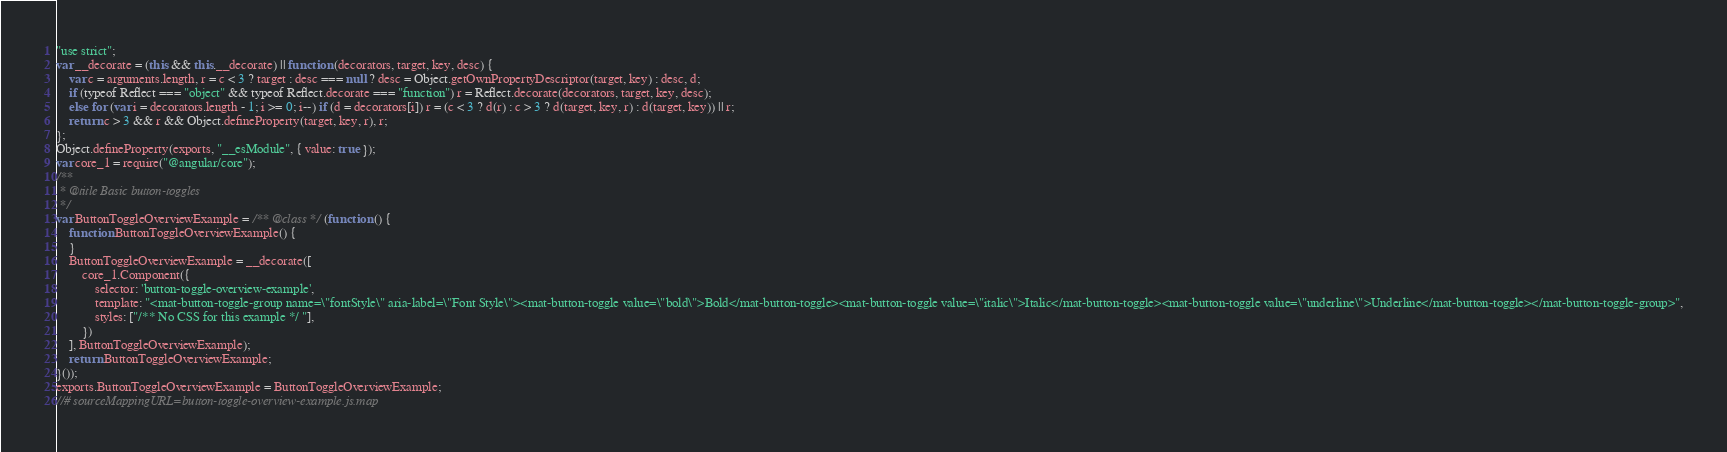Convert code to text. <code><loc_0><loc_0><loc_500><loc_500><_JavaScript_>"use strict";
var __decorate = (this && this.__decorate) || function (decorators, target, key, desc) {
    var c = arguments.length, r = c < 3 ? target : desc === null ? desc = Object.getOwnPropertyDescriptor(target, key) : desc, d;
    if (typeof Reflect === "object" && typeof Reflect.decorate === "function") r = Reflect.decorate(decorators, target, key, desc);
    else for (var i = decorators.length - 1; i >= 0; i--) if (d = decorators[i]) r = (c < 3 ? d(r) : c > 3 ? d(target, key, r) : d(target, key)) || r;
    return c > 3 && r && Object.defineProperty(target, key, r), r;
};
Object.defineProperty(exports, "__esModule", { value: true });
var core_1 = require("@angular/core");
/**
 * @title Basic button-toggles
 */
var ButtonToggleOverviewExample = /** @class */ (function () {
    function ButtonToggleOverviewExample() {
    }
    ButtonToggleOverviewExample = __decorate([
        core_1.Component({
            selector: 'button-toggle-overview-example',
            template: "<mat-button-toggle-group name=\"fontStyle\" aria-label=\"Font Style\"><mat-button-toggle value=\"bold\">Bold</mat-button-toggle><mat-button-toggle value=\"italic\">Italic</mat-button-toggle><mat-button-toggle value=\"underline\">Underline</mat-button-toggle></mat-button-toggle-group>",
            styles: ["/** No CSS for this example */ "],
        })
    ], ButtonToggleOverviewExample);
    return ButtonToggleOverviewExample;
}());
exports.ButtonToggleOverviewExample = ButtonToggleOverviewExample;
//# sourceMappingURL=button-toggle-overview-example.js.map</code> 